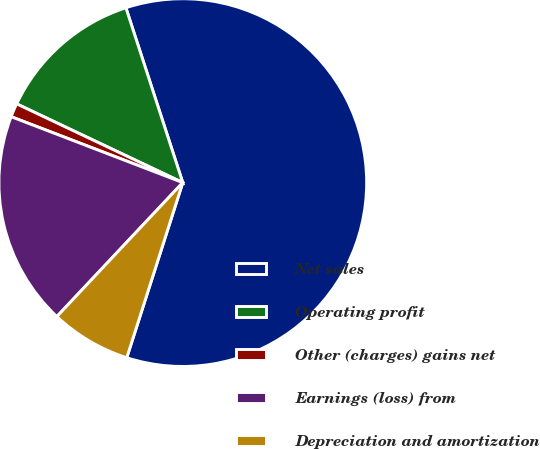Convert chart to OTSL. <chart><loc_0><loc_0><loc_500><loc_500><pie_chart><fcel>Net sales<fcel>Operating profit<fcel>Other (charges) gains net<fcel>Earnings (loss) from<fcel>Depreciation and amortization<nl><fcel>59.94%<fcel>12.95%<fcel>1.21%<fcel>18.83%<fcel>7.08%<nl></chart> 